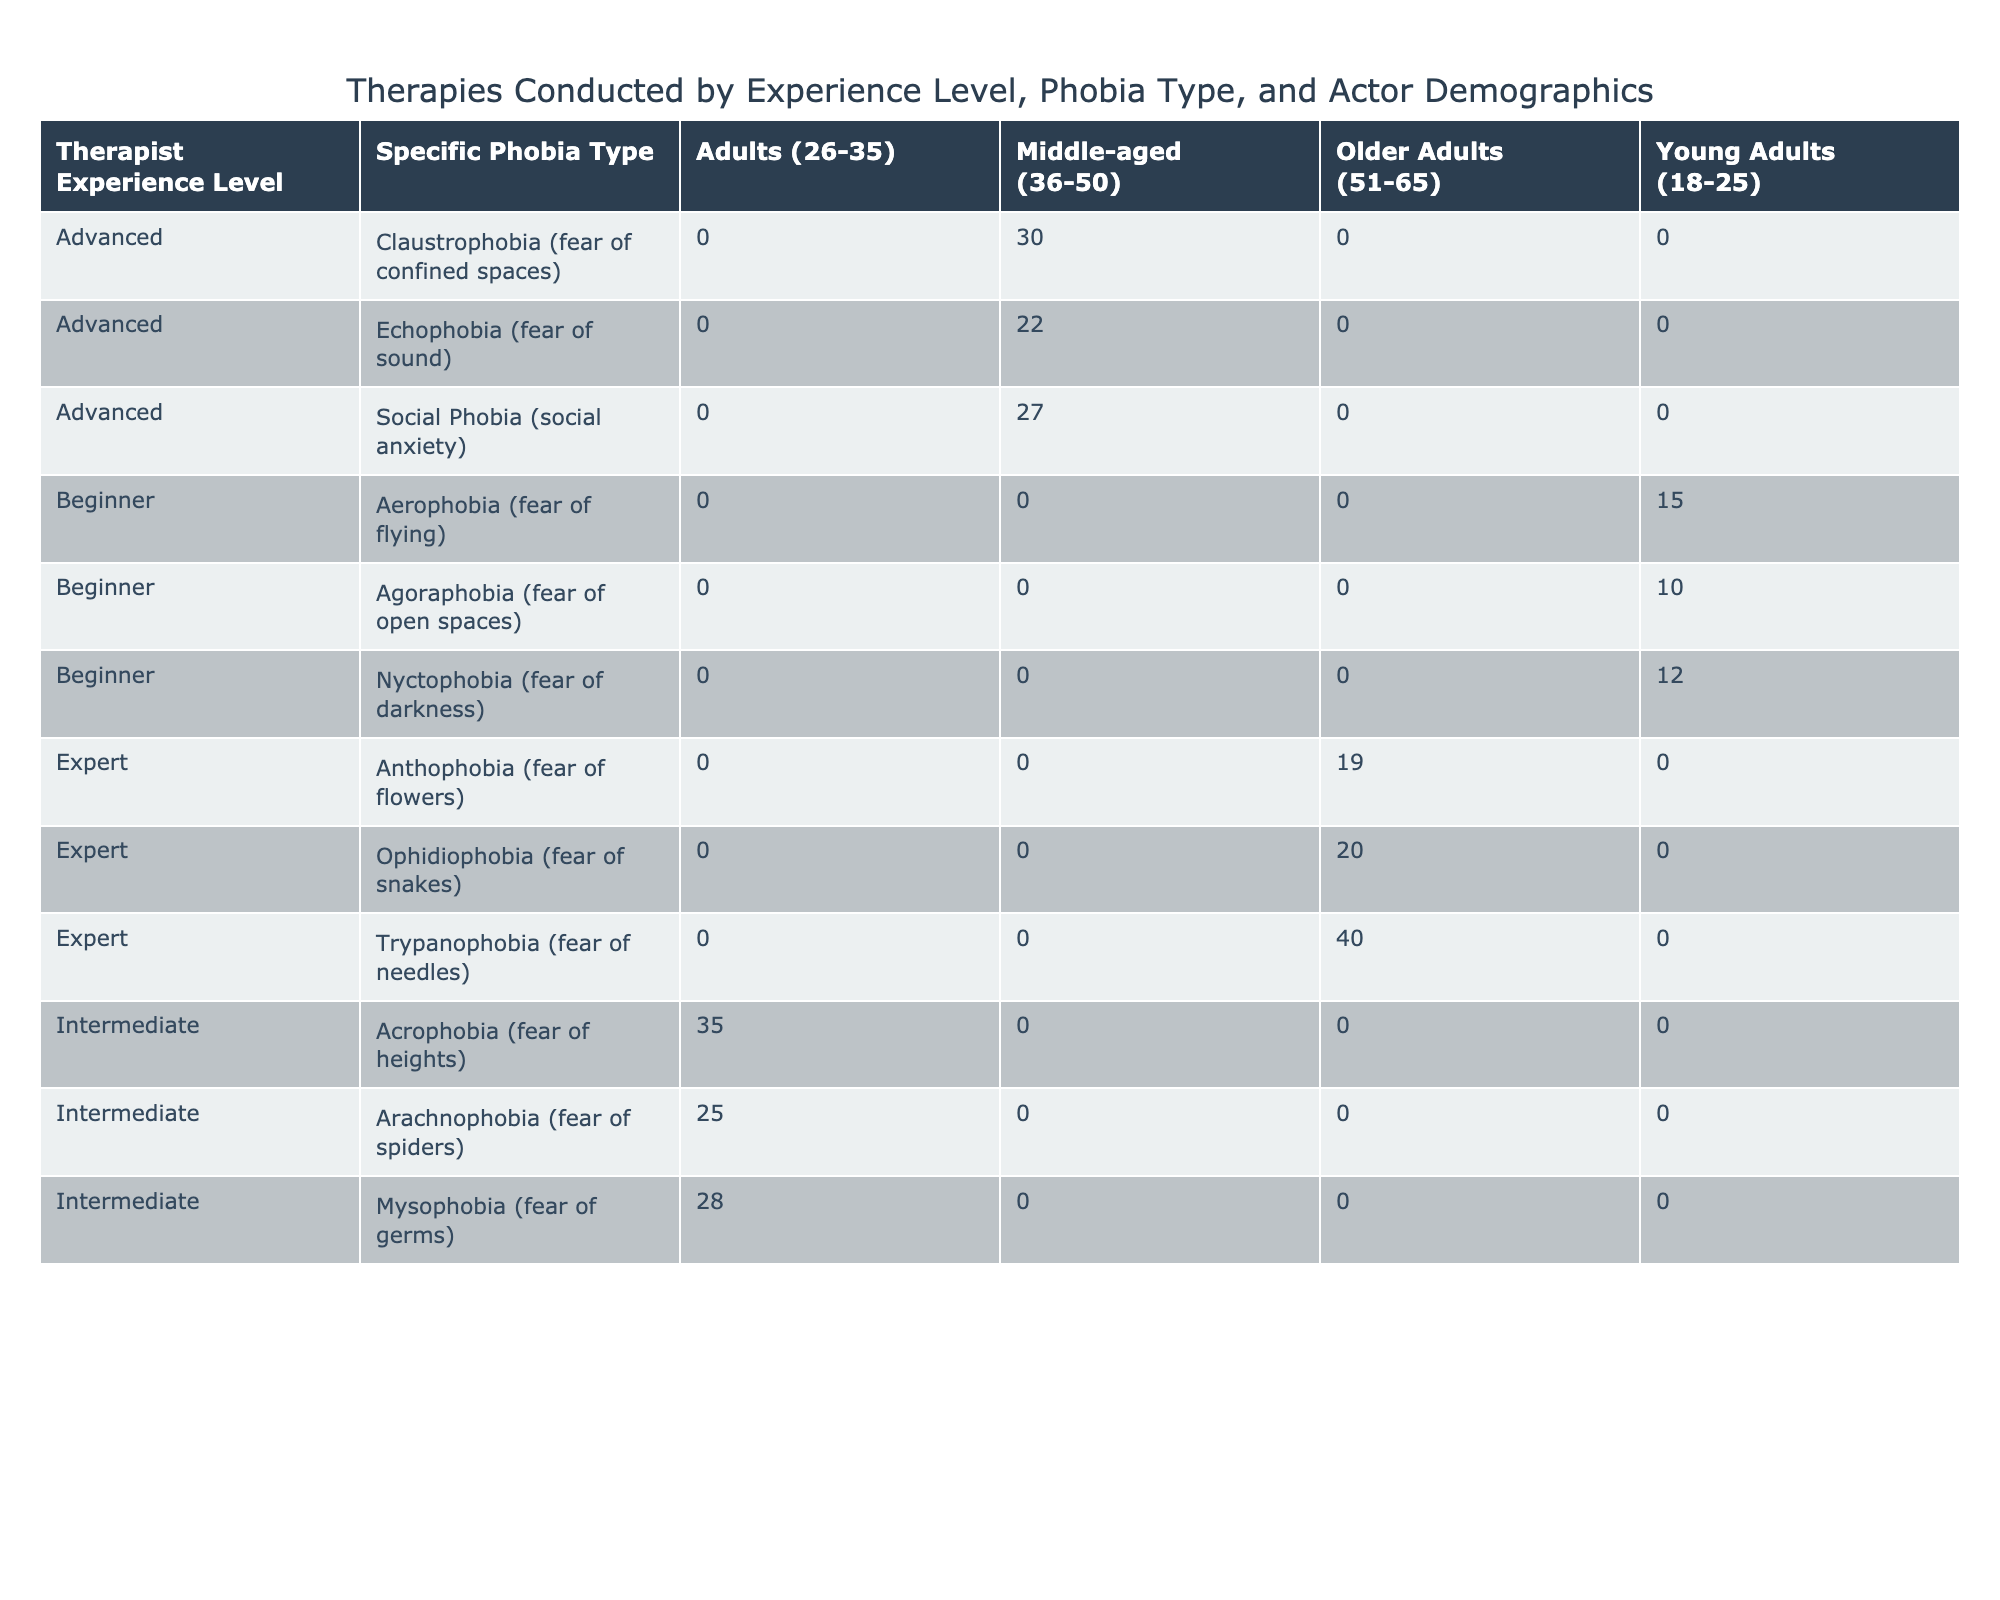What is the number of therapies conducted for Aerophobia by Beginner therapists? The table shows that for Aerophobia (fear of flying) and Beginner therapists, the number of therapies conducted is 15, as indicated in the corresponding row of the table.
Answer: 15 Which Actor Demographic had the highest number of therapies conducted for Acrophobia? The row for Acrophobia indicates that Adults (26-35) had the highest number of therapies conducted, which is 35. This is the only demographic listed for this specific phobia type, confirming it holds the highest value for Acrophobia.
Answer: Adults (26-35) How many total therapies did Expert therapists conduct across all specific phobias? To find the total therapies for Expert therapists, we need to sum the number of therapies for all specific phobia types under the Expert level. They conducted 20 for Ophidiophobia and 40 for Trypanophobia, totaling 20 + 40 = 60.
Answer: 60 Is it true that there are more therapies conducted for Nyctophobia by Beginner therapists than for Agoraphobia? The table states that Beginner therapists conducted 12 therapies for Nyctophobia and 10 for Agoraphobia, showing that there are indeed more therapies for Nyctophobia. Therefore, the statement is true.
Answer: Yes Which specific phobia type has the highest number of therapies conducted, and what is that amount? To determine this, we look at the maximum values across all rows for the number of therapies conducted. The highest figure is for Acrophobia, conducted by Intermediate therapists, with a value of 35. This is the overall highest number observed in the entire table.
Answer: Acrophobia, 35 How does the number of therapies for Social Phobia compare to those for Claustrophobia? Claustrophobia has 30 therapies conducted by Advanced therapists, while Social Phobia has 27 therapies conducted by Advanced therapists. Comparing these two shows that Claustrophobia has a higher number by 3 therapies (30 - 27 = 3).
Answer: Claustrophobia is higher by 3 therapies How many more therapies were conducted by Intermediate therapists compared to Beginner therapists for Arachnophobia? For Arachnophobia, the row shows that Intermediate therapists conducted 25 therapies, while Beginner therapists conducted 0. Thus, the difference is 25 - 0 = 25 therapies more for Intermediate therapists.
Answer: 25 more therapies Which Actor Demographic has had the same number of therapies conducted for both Echophobia and Social Phobia? Looking at the table, Middle-aged (36-50) has 22 therapies for Echophobia and 27 for Social Phobia. They do not have the same number of therapies conducted. This means there are no Actor Demographics that have the same amount for both.
Answer: No actor demographic with the same number for both 